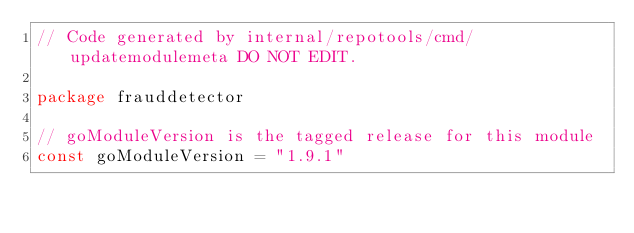Convert code to text. <code><loc_0><loc_0><loc_500><loc_500><_Go_>// Code generated by internal/repotools/cmd/updatemodulemeta DO NOT EDIT.

package frauddetector

// goModuleVersion is the tagged release for this module
const goModuleVersion = "1.9.1"
</code> 